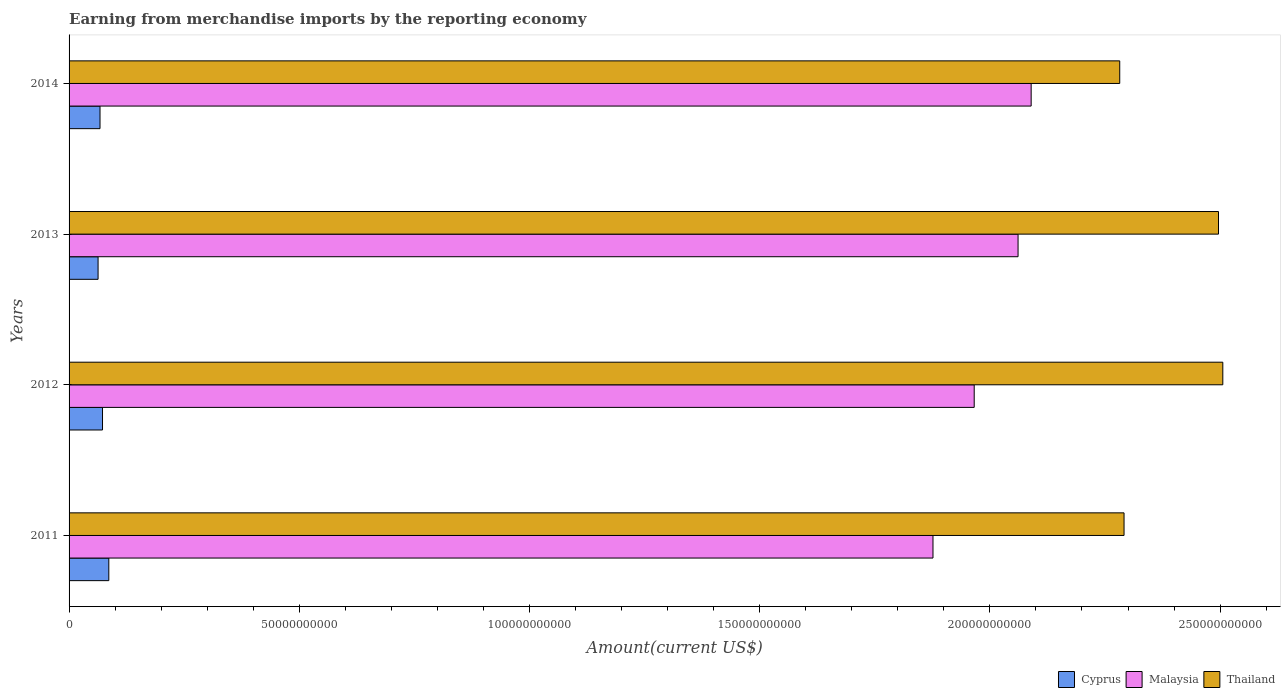How many different coloured bars are there?
Give a very brief answer. 3. How many groups of bars are there?
Your response must be concise. 4. Are the number of bars on each tick of the Y-axis equal?
Keep it short and to the point. Yes. How many bars are there on the 1st tick from the top?
Offer a terse response. 3. What is the amount earned from merchandise imports in Cyprus in 2014?
Keep it short and to the point. 6.72e+09. Across all years, what is the maximum amount earned from merchandise imports in Thailand?
Your response must be concise. 2.51e+11. Across all years, what is the minimum amount earned from merchandise imports in Malaysia?
Provide a short and direct response. 1.88e+11. What is the total amount earned from merchandise imports in Malaysia in the graph?
Your answer should be very brief. 7.99e+11. What is the difference between the amount earned from merchandise imports in Thailand in 2011 and that in 2014?
Keep it short and to the point. 9.36e+08. What is the difference between the amount earned from merchandise imports in Malaysia in 2011 and the amount earned from merchandise imports in Cyprus in 2014?
Offer a terse response. 1.81e+11. What is the average amount earned from merchandise imports in Malaysia per year?
Give a very brief answer. 2.00e+11. In the year 2014, what is the difference between the amount earned from merchandise imports in Thailand and amount earned from merchandise imports in Malaysia?
Provide a succinct answer. 1.92e+1. What is the ratio of the amount earned from merchandise imports in Thailand in 2012 to that in 2014?
Offer a very short reply. 1.1. Is the amount earned from merchandise imports in Thailand in 2012 less than that in 2014?
Provide a succinct answer. No. Is the difference between the amount earned from merchandise imports in Thailand in 2011 and 2014 greater than the difference between the amount earned from merchandise imports in Malaysia in 2011 and 2014?
Ensure brevity in your answer.  Yes. What is the difference between the highest and the second highest amount earned from merchandise imports in Thailand?
Provide a succinct answer. 9.36e+08. What is the difference between the highest and the lowest amount earned from merchandise imports in Thailand?
Provide a succinct answer. 2.24e+1. What does the 3rd bar from the top in 2012 represents?
Ensure brevity in your answer.  Cyprus. What does the 1st bar from the bottom in 2013 represents?
Your answer should be very brief. Cyprus. Is it the case that in every year, the sum of the amount earned from merchandise imports in Thailand and amount earned from merchandise imports in Malaysia is greater than the amount earned from merchandise imports in Cyprus?
Offer a very short reply. Yes. Are the values on the major ticks of X-axis written in scientific E-notation?
Offer a terse response. No. Where does the legend appear in the graph?
Keep it short and to the point. Bottom right. How many legend labels are there?
Offer a very short reply. 3. What is the title of the graph?
Make the answer very short. Earning from merchandise imports by the reporting economy. What is the label or title of the X-axis?
Give a very brief answer. Amount(current US$). What is the label or title of the Y-axis?
Your answer should be compact. Years. What is the Amount(current US$) of Cyprus in 2011?
Your response must be concise. 8.63e+09. What is the Amount(current US$) of Malaysia in 2011?
Your answer should be very brief. 1.88e+11. What is the Amount(current US$) of Thailand in 2011?
Ensure brevity in your answer.  2.29e+11. What is the Amount(current US$) of Cyprus in 2012?
Offer a very short reply. 7.26e+09. What is the Amount(current US$) in Malaysia in 2012?
Your answer should be very brief. 1.97e+11. What is the Amount(current US$) in Thailand in 2012?
Your answer should be compact. 2.51e+11. What is the Amount(current US$) in Cyprus in 2013?
Keep it short and to the point. 6.30e+09. What is the Amount(current US$) of Malaysia in 2013?
Your answer should be very brief. 2.06e+11. What is the Amount(current US$) of Thailand in 2013?
Your answer should be compact. 2.50e+11. What is the Amount(current US$) of Cyprus in 2014?
Keep it short and to the point. 6.72e+09. What is the Amount(current US$) of Malaysia in 2014?
Provide a succinct answer. 2.09e+11. What is the Amount(current US$) of Thailand in 2014?
Give a very brief answer. 2.28e+11. Across all years, what is the maximum Amount(current US$) of Cyprus?
Your answer should be very brief. 8.63e+09. Across all years, what is the maximum Amount(current US$) in Malaysia?
Provide a succinct answer. 2.09e+11. Across all years, what is the maximum Amount(current US$) of Thailand?
Your answer should be compact. 2.51e+11. Across all years, what is the minimum Amount(current US$) in Cyprus?
Keep it short and to the point. 6.30e+09. Across all years, what is the minimum Amount(current US$) of Malaysia?
Ensure brevity in your answer.  1.88e+11. Across all years, what is the minimum Amount(current US$) of Thailand?
Your answer should be very brief. 2.28e+11. What is the total Amount(current US$) in Cyprus in the graph?
Provide a short and direct response. 2.89e+1. What is the total Amount(current US$) of Malaysia in the graph?
Offer a terse response. 7.99e+11. What is the total Amount(current US$) of Thailand in the graph?
Keep it short and to the point. 9.58e+11. What is the difference between the Amount(current US$) in Cyprus in 2011 and that in 2012?
Offer a terse response. 1.37e+09. What is the difference between the Amount(current US$) in Malaysia in 2011 and that in 2012?
Ensure brevity in your answer.  -8.95e+09. What is the difference between the Amount(current US$) of Thailand in 2011 and that in 2012?
Make the answer very short. -2.15e+1. What is the difference between the Amount(current US$) in Cyprus in 2011 and that in 2013?
Offer a terse response. 2.33e+09. What is the difference between the Amount(current US$) in Malaysia in 2011 and that in 2013?
Make the answer very short. -1.85e+1. What is the difference between the Amount(current US$) of Thailand in 2011 and that in 2013?
Your response must be concise. -2.05e+1. What is the difference between the Amount(current US$) in Cyprus in 2011 and that in 2014?
Keep it short and to the point. 1.91e+09. What is the difference between the Amount(current US$) in Malaysia in 2011 and that in 2014?
Your answer should be compact. -2.13e+1. What is the difference between the Amount(current US$) in Thailand in 2011 and that in 2014?
Your answer should be compact. 9.36e+08. What is the difference between the Amount(current US$) of Cyprus in 2012 and that in 2013?
Keep it short and to the point. 9.65e+08. What is the difference between the Amount(current US$) in Malaysia in 2012 and that in 2013?
Provide a succinct answer. -9.53e+09. What is the difference between the Amount(current US$) in Thailand in 2012 and that in 2013?
Your answer should be compact. 9.36e+08. What is the difference between the Amount(current US$) in Cyprus in 2012 and that in 2014?
Give a very brief answer. 5.42e+08. What is the difference between the Amount(current US$) in Malaysia in 2012 and that in 2014?
Give a very brief answer. -1.24e+1. What is the difference between the Amount(current US$) in Thailand in 2012 and that in 2014?
Your answer should be very brief. 2.24e+1. What is the difference between the Amount(current US$) in Cyprus in 2013 and that in 2014?
Ensure brevity in your answer.  -4.22e+08. What is the difference between the Amount(current US$) in Malaysia in 2013 and that in 2014?
Your answer should be compact. -2.84e+09. What is the difference between the Amount(current US$) of Thailand in 2013 and that in 2014?
Make the answer very short. 2.15e+1. What is the difference between the Amount(current US$) in Cyprus in 2011 and the Amount(current US$) in Malaysia in 2012?
Your answer should be compact. -1.88e+11. What is the difference between the Amount(current US$) in Cyprus in 2011 and the Amount(current US$) in Thailand in 2012?
Provide a succinct answer. -2.42e+11. What is the difference between the Amount(current US$) of Malaysia in 2011 and the Amount(current US$) of Thailand in 2012?
Provide a short and direct response. -6.29e+1. What is the difference between the Amount(current US$) in Cyprus in 2011 and the Amount(current US$) in Malaysia in 2013?
Make the answer very short. -1.97e+11. What is the difference between the Amount(current US$) of Cyprus in 2011 and the Amount(current US$) of Thailand in 2013?
Provide a succinct answer. -2.41e+11. What is the difference between the Amount(current US$) in Malaysia in 2011 and the Amount(current US$) in Thailand in 2013?
Provide a short and direct response. -6.20e+1. What is the difference between the Amount(current US$) of Cyprus in 2011 and the Amount(current US$) of Malaysia in 2014?
Make the answer very short. -2.00e+11. What is the difference between the Amount(current US$) in Cyprus in 2011 and the Amount(current US$) in Thailand in 2014?
Offer a terse response. -2.20e+11. What is the difference between the Amount(current US$) in Malaysia in 2011 and the Amount(current US$) in Thailand in 2014?
Your response must be concise. -4.06e+1. What is the difference between the Amount(current US$) of Cyprus in 2012 and the Amount(current US$) of Malaysia in 2013?
Offer a very short reply. -1.99e+11. What is the difference between the Amount(current US$) in Cyprus in 2012 and the Amount(current US$) in Thailand in 2013?
Provide a succinct answer. -2.42e+11. What is the difference between the Amount(current US$) of Malaysia in 2012 and the Amount(current US$) of Thailand in 2013?
Offer a very short reply. -5.31e+1. What is the difference between the Amount(current US$) of Cyprus in 2012 and the Amount(current US$) of Malaysia in 2014?
Make the answer very short. -2.02e+11. What is the difference between the Amount(current US$) in Cyprus in 2012 and the Amount(current US$) in Thailand in 2014?
Make the answer very short. -2.21e+11. What is the difference between the Amount(current US$) of Malaysia in 2012 and the Amount(current US$) of Thailand in 2014?
Make the answer very short. -3.16e+1. What is the difference between the Amount(current US$) in Cyprus in 2013 and the Amount(current US$) in Malaysia in 2014?
Provide a succinct answer. -2.03e+11. What is the difference between the Amount(current US$) in Cyprus in 2013 and the Amount(current US$) in Thailand in 2014?
Your answer should be very brief. -2.22e+11. What is the difference between the Amount(current US$) of Malaysia in 2013 and the Amount(current US$) of Thailand in 2014?
Give a very brief answer. -2.21e+1. What is the average Amount(current US$) in Cyprus per year?
Offer a terse response. 7.23e+09. What is the average Amount(current US$) in Malaysia per year?
Ensure brevity in your answer.  2.00e+11. What is the average Amount(current US$) in Thailand per year?
Provide a short and direct response. 2.39e+11. In the year 2011, what is the difference between the Amount(current US$) in Cyprus and Amount(current US$) in Malaysia?
Provide a short and direct response. -1.79e+11. In the year 2011, what is the difference between the Amount(current US$) in Cyprus and Amount(current US$) in Thailand?
Keep it short and to the point. -2.21e+11. In the year 2011, what is the difference between the Amount(current US$) in Malaysia and Amount(current US$) in Thailand?
Offer a terse response. -4.15e+1. In the year 2012, what is the difference between the Amount(current US$) in Cyprus and Amount(current US$) in Malaysia?
Provide a short and direct response. -1.89e+11. In the year 2012, what is the difference between the Amount(current US$) in Cyprus and Amount(current US$) in Thailand?
Your answer should be compact. -2.43e+11. In the year 2012, what is the difference between the Amount(current US$) of Malaysia and Amount(current US$) of Thailand?
Ensure brevity in your answer.  -5.40e+1. In the year 2013, what is the difference between the Amount(current US$) of Cyprus and Amount(current US$) of Malaysia?
Give a very brief answer. -2.00e+11. In the year 2013, what is the difference between the Amount(current US$) of Cyprus and Amount(current US$) of Thailand?
Your response must be concise. -2.43e+11. In the year 2013, what is the difference between the Amount(current US$) of Malaysia and Amount(current US$) of Thailand?
Offer a terse response. -4.35e+1. In the year 2014, what is the difference between the Amount(current US$) of Cyprus and Amount(current US$) of Malaysia?
Provide a short and direct response. -2.02e+11. In the year 2014, what is the difference between the Amount(current US$) in Cyprus and Amount(current US$) in Thailand?
Your response must be concise. -2.21e+11. In the year 2014, what is the difference between the Amount(current US$) of Malaysia and Amount(current US$) of Thailand?
Your response must be concise. -1.92e+1. What is the ratio of the Amount(current US$) of Cyprus in 2011 to that in 2012?
Your answer should be compact. 1.19. What is the ratio of the Amount(current US$) of Malaysia in 2011 to that in 2012?
Ensure brevity in your answer.  0.95. What is the ratio of the Amount(current US$) of Thailand in 2011 to that in 2012?
Provide a short and direct response. 0.91. What is the ratio of the Amount(current US$) in Cyprus in 2011 to that in 2013?
Ensure brevity in your answer.  1.37. What is the ratio of the Amount(current US$) of Malaysia in 2011 to that in 2013?
Your response must be concise. 0.91. What is the ratio of the Amount(current US$) of Thailand in 2011 to that in 2013?
Make the answer very short. 0.92. What is the ratio of the Amount(current US$) in Cyprus in 2011 to that in 2014?
Ensure brevity in your answer.  1.28. What is the ratio of the Amount(current US$) in Malaysia in 2011 to that in 2014?
Give a very brief answer. 0.9. What is the ratio of the Amount(current US$) of Cyprus in 2012 to that in 2013?
Offer a very short reply. 1.15. What is the ratio of the Amount(current US$) of Malaysia in 2012 to that in 2013?
Provide a succinct answer. 0.95. What is the ratio of the Amount(current US$) in Thailand in 2012 to that in 2013?
Your answer should be very brief. 1. What is the ratio of the Amount(current US$) in Cyprus in 2012 to that in 2014?
Keep it short and to the point. 1.08. What is the ratio of the Amount(current US$) of Malaysia in 2012 to that in 2014?
Your response must be concise. 0.94. What is the ratio of the Amount(current US$) of Thailand in 2012 to that in 2014?
Your answer should be compact. 1.1. What is the ratio of the Amount(current US$) in Cyprus in 2013 to that in 2014?
Your response must be concise. 0.94. What is the ratio of the Amount(current US$) in Malaysia in 2013 to that in 2014?
Keep it short and to the point. 0.99. What is the ratio of the Amount(current US$) in Thailand in 2013 to that in 2014?
Your response must be concise. 1.09. What is the difference between the highest and the second highest Amount(current US$) of Cyprus?
Your response must be concise. 1.37e+09. What is the difference between the highest and the second highest Amount(current US$) in Malaysia?
Your response must be concise. 2.84e+09. What is the difference between the highest and the second highest Amount(current US$) of Thailand?
Give a very brief answer. 9.36e+08. What is the difference between the highest and the lowest Amount(current US$) of Cyprus?
Your answer should be compact. 2.33e+09. What is the difference between the highest and the lowest Amount(current US$) in Malaysia?
Your response must be concise. 2.13e+1. What is the difference between the highest and the lowest Amount(current US$) of Thailand?
Provide a succinct answer. 2.24e+1. 